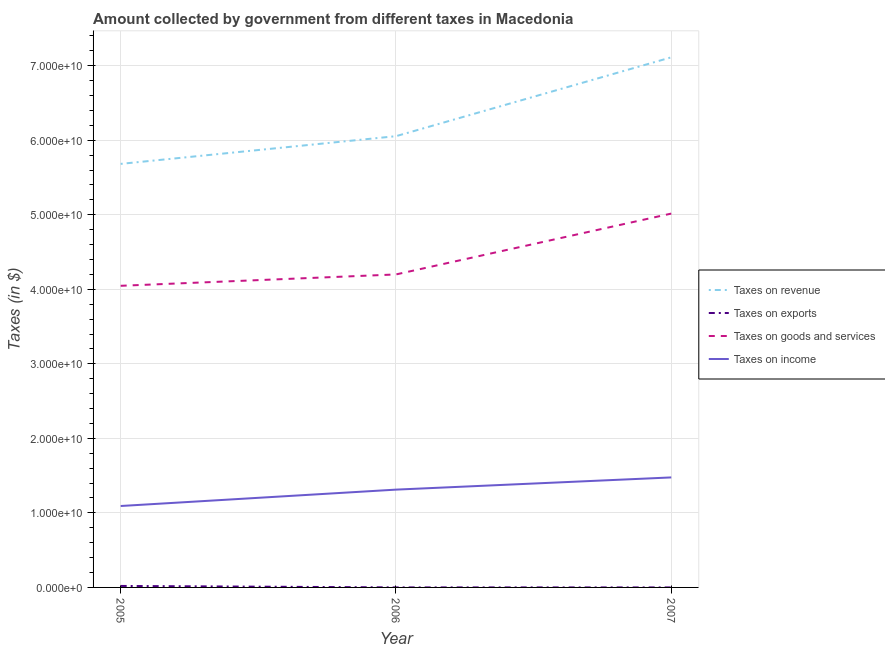How many different coloured lines are there?
Offer a terse response. 4. Is the number of lines equal to the number of legend labels?
Keep it short and to the point. Yes. What is the amount collected as tax on goods in 2005?
Your answer should be compact. 4.05e+1. Across all years, what is the maximum amount collected as tax on exports?
Offer a very short reply. 1.99e+08. Across all years, what is the minimum amount collected as tax on revenue?
Your answer should be very brief. 5.68e+1. In which year was the amount collected as tax on revenue minimum?
Your answer should be very brief. 2005. What is the total amount collected as tax on goods in the graph?
Provide a succinct answer. 1.33e+11. What is the difference between the amount collected as tax on income in 2005 and that in 2006?
Make the answer very short. -2.20e+09. What is the difference between the amount collected as tax on income in 2007 and the amount collected as tax on goods in 2006?
Provide a short and direct response. -2.72e+1. What is the average amount collected as tax on income per year?
Ensure brevity in your answer.  1.29e+1. In the year 2005, what is the difference between the amount collected as tax on goods and amount collected as tax on income?
Provide a succinct answer. 2.95e+1. What is the ratio of the amount collected as tax on income in 2006 to that in 2007?
Offer a very short reply. 0.89. Is the amount collected as tax on revenue in 2005 less than that in 2007?
Give a very brief answer. Yes. Is the difference between the amount collected as tax on goods in 2006 and 2007 greater than the difference between the amount collected as tax on income in 2006 and 2007?
Offer a terse response. No. What is the difference between the highest and the second highest amount collected as tax on exports?
Give a very brief answer. 1.95e+08. What is the difference between the highest and the lowest amount collected as tax on revenue?
Ensure brevity in your answer.  1.43e+1. In how many years, is the amount collected as tax on income greater than the average amount collected as tax on income taken over all years?
Give a very brief answer. 2. Is the sum of the amount collected as tax on income in 2006 and 2007 greater than the maximum amount collected as tax on revenue across all years?
Offer a very short reply. No. Is the amount collected as tax on goods strictly greater than the amount collected as tax on exports over the years?
Your response must be concise. Yes. How many lines are there?
Keep it short and to the point. 4. How many years are there in the graph?
Give a very brief answer. 3. Are the values on the major ticks of Y-axis written in scientific E-notation?
Your response must be concise. Yes. Does the graph contain grids?
Your answer should be very brief. Yes. How are the legend labels stacked?
Ensure brevity in your answer.  Vertical. What is the title of the graph?
Give a very brief answer. Amount collected by government from different taxes in Macedonia. Does "Pre-primary schools" appear as one of the legend labels in the graph?
Provide a short and direct response. No. What is the label or title of the X-axis?
Keep it short and to the point. Year. What is the label or title of the Y-axis?
Provide a short and direct response. Taxes (in $). What is the Taxes (in $) in Taxes on revenue in 2005?
Your answer should be very brief. 5.68e+1. What is the Taxes (in $) of Taxes on exports in 2005?
Provide a succinct answer. 1.99e+08. What is the Taxes (in $) of Taxes on goods and services in 2005?
Your answer should be very brief. 4.05e+1. What is the Taxes (in $) in Taxes on income in 2005?
Offer a very short reply. 1.09e+1. What is the Taxes (in $) in Taxes on revenue in 2006?
Keep it short and to the point. 6.05e+1. What is the Taxes (in $) in Taxes on exports in 2006?
Provide a short and direct response. 3.90e+06. What is the Taxes (in $) of Taxes on goods and services in 2006?
Provide a succinct answer. 4.20e+1. What is the Taxes (in $) of Taxes on income in 2006?
Your response must be concise. 1.31e+1. What is the Taxes (in $) in Taxes on revenue in 2007?
Keep it short and to the point. 7.11e+1. What is the Taxes (in $) of Taxes on exports in 2007?
Make the answer very short. 1.31e+04. What is the Taxes (in $) of Taxes on goods and services in 2007?
Give a very brief answer. 5.02e+1. What is the Taxes (in $) of Taxes on income in 2007?
Give a very brief answer. 1.48e+1. Across all years, what is the maximum Taxes (in $) in Taxes on revenue?
Ensure brevity in your answer.  7.11e+1. Across all years, what is the maximum Taxes (in $) in Taxes on exports?
Ensure brevity in your answer.  1.99e+08. Across all years, what is the maximum Taxes (in $) of Taxes on goods and services?
Give a very brief answer. 5.02e+1. Across all years, what is the maximum Taxes (in $) in Taxes on income?
Your response must be concise. 1.48e+1. Across all years, what is the minimum Taxes (in $) in Taxes on revenue?
Provide a short and direct response. 5.68e+1. Across all years, what is the minimum Taxes (in $) of Taxes on exports?
Your answer should be very brief. 1.31e+04. Across all years, what is the minimum Taxes (in $) of Taxes on goods and services?
Keep it short and to the point. 4.05e+1. Across all years, what is the minimum Taxes (in $) in Taxes on income?
Ensure brevity in your answer.  1.09e+1. What is the total Taxes (in $) of Taxes on revenue in the graph?
Offer a terse response. 1.89e+11. What is the total Taxes (in $) of Taxes on exports in the graph?
Keep it short and to the point. 2.03e+08. What is the total Taxes (in $) in Taxes on goods and services in the graph?
Your answer should be very brief. 1.33e+11. What is the total Taxes (in $) in Taxes on income in the graph?
Offer a very short reply. 3.88e+1. What is the difference between the Taxes (in $) of Taxes on revenue in 2005 and that in 2006?
Your answer should be compact. -3.72e+09. What is the difference between the Taxes (in $) of Taxes on exports in 2005 and that in 2006?
Provide a short and direct response. 1.95e+08. What is the difference between the Taxes (in $) in Taxes on goods and services in 2005 and that in 2006?
Offer a terse response. -1.52e+09. What is the difference between the Taxes (in $) of Taxes on income in 2005 and that in 2006?
Keep it short and to the point. -2.20e+09. What is the difference between the Taxes (in $) of Taxes on revenue in 2005 and that in 2007?
Your answer should be very brief. -1.43e+1. What is the difference between the Taxes (in $) of Taxes on exports in 2005 and that in 2007?
Keep it short and to the point. 1.99e+08. What is the difference between the Taxes (in $) of Taxes on goods and services in 2005 and that in 2007?
Your response must be concise. -9.69e+09. What is the difference between the Taxes (in $) in Taxes on income in 2005 and that in 2007?
Give a very brief answer. -3.83e+09. What is the difference between the Taxes (in $) of Taxes on revenue in 2006 and that in 2007?
Ensure brevity in your answer.  -1.06e+1. What is the difference between the Taxes (in $) in Taxes on exports in 2006 and that in 2007?
Make the answer very short. 3.88e+06. What is the difference between the Taxes (in $) of Taxes on goods and services in 2006 and that in 2007?
Keep it short and to the point. -8.17e+09. What is the difference between the Taxes (in $) of Taxes on income in 2006 and that in 2007?
Your response must be concise. -1.64e+09. What is the difference between the Taxes (in $) of Taxes on revenue in 2005 and the Taxes (in $) of Taxes on exports in 2006?
Offer a very short reply. 5.68e+1. What is the difference between the Taxes (in $) of Taxes on revenue in 2005 and the Taxes (in $) of Taxes on goods and services in 2006?
Offer a terse response. 1.48e+1. What is the difference between the Taxes (in $) in Taxes on revenue in 2005 and the Taxes (in $) in Taxes on income in 2006?
Offer a very short reply. 4.37e+1. What is the difference between the Taxes (in $) in Taxes on exports in 2005 and the Taxes (in $) in Taxes on goods and services in 2006?
Make the answer very short. -4.18e+1. What is the difference between the Taxes (in $) of Taxes on exports in 2005 and the Taxes (in $) of Taxes on income in 2006?
Your answer should be very brief. -1.29e+1. What is the difference between the Taxes (in $) in Taxes on goods and services in 2005 and the Taxes (in $) in Taxes on income in 2006?
Offer a very short reply. 2.74e+1. What is the difference between the Taxes (in $) of Taxes on revenue in 2005 and the Taxes (in $) of Taxes on exports in 2007?
Give a very brief answer. 5.68e+1. What is the difference between the Taxes (in $) in Taxes on revenue in 2005 and the Taxes (in $) in Taxes on goods and services in 2007?
Your response must be concise. 6.67e+09. What is the difference between the Taxes (in $) of Taxes on revenue in 2005 and the Taxes (in $) of Taxes on income in 2007?
Provide a short and direct response. 4.21e+1. What is the difference between the Taxes (in $) in Taxes on exports in 2005 and the Taxes (in $) in Taxes on goods and services in 2007?
Make the answer very short. -5.00e+1. What is the difference between the Taxes (in $) of Taxes on exports in 2005 and the Taxes (in $) of Taxes on income in 2007?
Your answer should be compact. -1.46e+1. What is the difference between the Taxes (in $) in Taxes on goods and services in 2005 and the Taxes (in $) in Taxes on income in 2007?
Make the answer very short. 2.57e+1. What is the difference between the Taxes (in $) in Taxes on revenue in 2006 and the Taxes (in $) in Taxes on exports in 2007?
Your response must be concise. 6.05e+1. What is the difference between the Taxes (in $) of Taxes on revenue in 2006 and the Taxes (in $) of Taxes on goods and services in 2007?
Make the answer very short. 1.04e+1. What is the difference between the Taxes (in $) of Taxes on revenue in 2006 and the Taxes (in $) of Taxes on income in 2007?
Provide a succinct answer. 4.58e+1. What is the difference between the Taxes (in $) in Taxes on exports in 2006 and the Taxes (in $) in Taxes on goods and services in 2007?
Your answer should be compact. -5.02e+1. What is the difference between the Taxes (in $) in Taxes on exports in 2006 and the Taxes (in $) in Taxes on income in 2007?
Offer a terse response. -1.48e+1. What is the difference between the Taxes (in $) of Taxes on goods and services in 2006 and the Taxes (in $) of Taxes on income in 2007?
Your answer should be compact. 2.72e+1. What is the average Taxes (in $) in Taxes on revenue per year?
Ensure brevity in your answer.  6.28e+1. What is the average Taxes (in $) in Taxes on exports per year?
Keep it short and to the point. 6.77e+07. What is the average Taxes (in $) in Taxes on goods and services per year?
Your answer should be compact. 4.42e+1. What is the average Taxes (in $) in Taxes on income per year?
Offer a terse response. 1.29e+1. In the year 2005, what is the difference between the Taxes (in $) of Taxes on revenue and Taxes (in $) of Taxes on exports?
Offer a very short reply. 5.66e+1. In the year 2005, what is the difference between the Taxes (in $) in Taxes on revenue and Taxes (in $) in Taxes on goods and services?
Keep it short and to the point. 1.64e+1. In the year 2005, what is the difference between the Taxes (in $) of Taxes on revenue and Taxes (in $) of Taxes on income?
Make the answer very short. 4.59e+1. In the year 2005, what is the difference between the Taxes (in $) of Taxes on exports and Taxes (in $) of Taxes on goods and services?
Make the answer very short. -4.03e+1. In the year 2005, what is the difference between the Taxes (in $) in Taxes on exports and Taxes (in $) in Taxes on income?
Give a very brief answer. -1.07e+1. In the year 2005, what is the difference between the Taxes (in $) of Taxes on goods and services and Taxes (in $) of Taxes on income?
Your answer should be compact. 2.95e+1. In the year 2006, what is the difference between the Taxes (in $) in Taxes on revenue and Taxes (in $) in Taxes on exports?
Your answer should be compact. 6.05e+1. In the year 2006, what is the difference between the Taxes (in $) of Taxes on revenue and Taxes (in $) of Taxes on goods and services?
Make the answer very short. 1.86e+1. In the year 2006, what is the difference between the Taxes (in $) of Taxes on revenue and Taxes (in $) of Taxes on income?
Give a very brief answer. 4.74e+1. In the year 2006, what is the difference between the Taxes (in $) in Taxes on exports and Taxes (in $) in Taxes on goods and services?
Provide a succinct answer. -4.20e+1. In the year 2006, what is the difference between the Taxes (in $) in Taxes on exports and Taxes (in $) in Taxes on income?
Your answer should be compact. -1.31e+1. In the year 2006, what is the difference between the Taxes (in $) in Taxes on goods and services and Taxes (in $) in Taxes on income?
Give a very brief answer. 2.89e+1. In the year 2007, what is the difference between the Taxes (in $) of Taxes on revenue and Taxes (in $) of Taxes on exports?
Offer a very short reply. 7.11e+1. In the year 2007, what is the difference between the Taxes (in $) of Taxes on revenue and Taxes (in $) of Taxes on goods and services?
Keep it short and to the point. 2.10e+1. In the year 2007, what is the difference between the Taxes (in $) of Taxes on revenue and Taxes (in $) of Taxes on income?
Ensure brevity in your answer.  5.64e+1. In the year 2007, what is the difference between the Taxes (in $) in Taxes on exports and Taxes (in $) in Taxes on goods and services?
Your answer should be compact. -5.02e+1. In the year 2007, what is the difference between the Taxes (in $) in Taxes on exports and Taxes (in $) in Taxes on income?
Ensure brevity in your answer.  -1.48e+1. In the year 2007, what is the difference between the Taxes (in $) in Taxes on goods and services and Taxes (in $) in Taxes on income?
Your response must be concise. 3.54e+1. What is the ratio of the Taxes (in $) of Taxes on revenue in 2005 to that in 2006?
Give a very brief answer. 0.94. What is the ratio of the Taxes (in $) of Taxes on exports in 2005 to that in 2006?
Keep it short and to the point. 51.11. What is the ratio of the Taxes (in $) in Taxes on goods and services in 2005 to that in 2006?
Offer a terse response. 0.96. What is the ratio of the Taxes (in $) of Taxes on income in 2005 to that in 2006?
Provide a short and direct response. 0.83. What is the ratio of the Taxes (in $) in Taxes on revenue in 2005 to that in 2007?
Your answer should be compact. 0.8. What is the ratio of the Taxes (in $) in Taxes on exports in 2005 to that in 2007?
Ensure brevity in your answer.  1.52e+04. What is the ratio of the Taxes (in $) of Taxes on goods and services in 2005 to that in 2007?
Provide a short and direct response. 0.81. What is the ratio of the Taxes (in $) of Taxes on income in 2005 to that in 2007?
Offer a terse response. 0.74. What is the ratio of the Taxes (in $) in Taxes on revenue in 2006 to that in 2007?
Ensure brevity in your answer.  0.85. What is the ratio of the Taxes (in $) of Taxes on exports in 2006 to that in 2007?
Make the answer very short. 297.99. What is the ratio of the Taxes (in $) of Taxes on goods and services in 2006 to that in 2007?
Make the answer very short. 0.84. What is the ratio of the Taxes (in $) of Taxes on income in 2006 to that in 2007?
Offer a very short reply. 0.89. What is the difference between the highest and the second highest Taxes (in $) of Taxes on revenue?
Offer a terse response. 1.06e+1. What is the difference between the highest and the second highest Taxes (in $) of Taxes on exports?
Provide a succinct answer. 1.95e+08. What is the difference between the highest and the second highest Taxes (in $) of Taxes on goods and services?
Your answer should be compact. 8.17e+09. What is the difference between the highest and the second highest Taxes (in $) of Taxes on income?
Provide a short and direct response. 1.64e+09. What is the difference between the highest and the lowest Taxes (in $) in Taxes on revenue?
Your response must be concise. 1.43e+1. What is the difference between the highest and the lowest Taxes (in $) of Taxes on exports?
Provide a succinct answer. 1.99e+08. What is the difference between the highest and the lowest Taxes (in $) of Taxes on goods and services?
Offer a terse response. 9.69e+09. What is the difference between the highest and the lowest Taxes (in $) of Taxes on income?
Provide a short and direct response. 3.83e+09. 